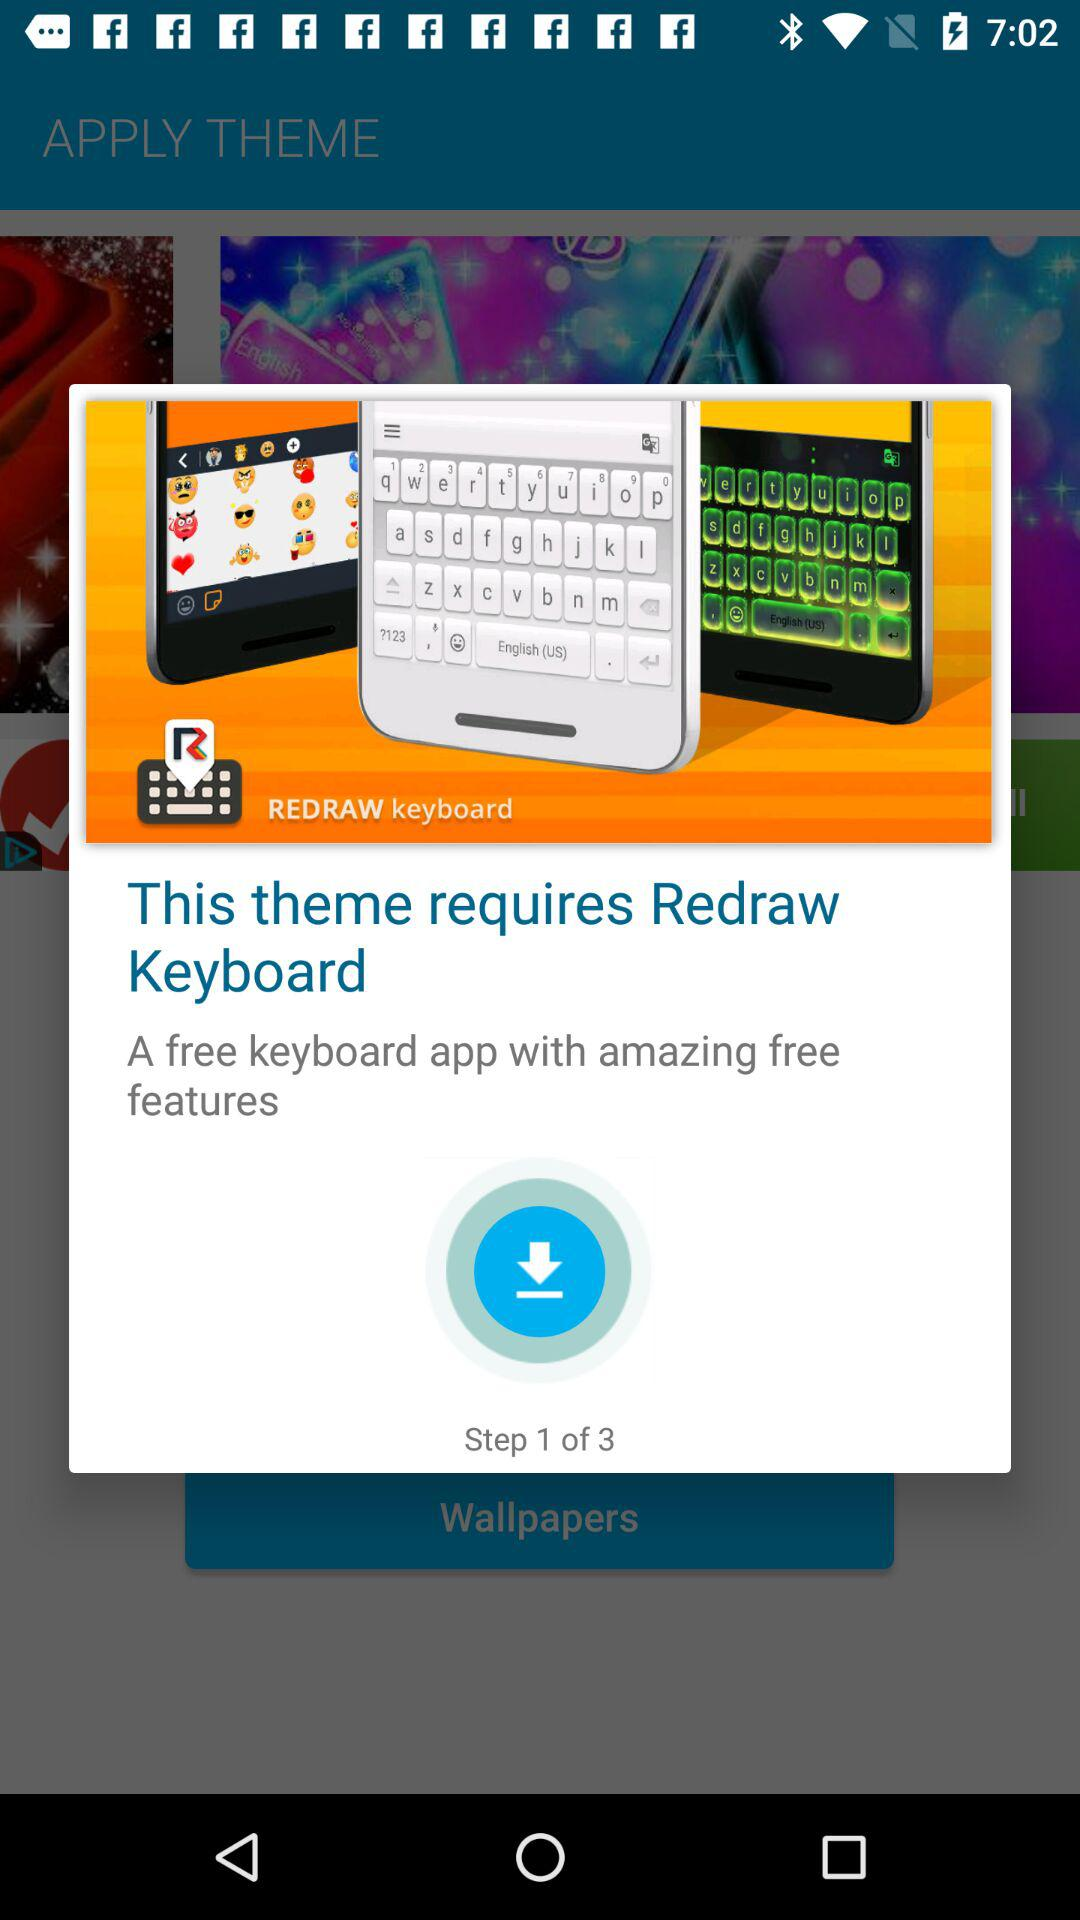How many steps are there in this process?
Answer the question using a single word or phrase. 3 